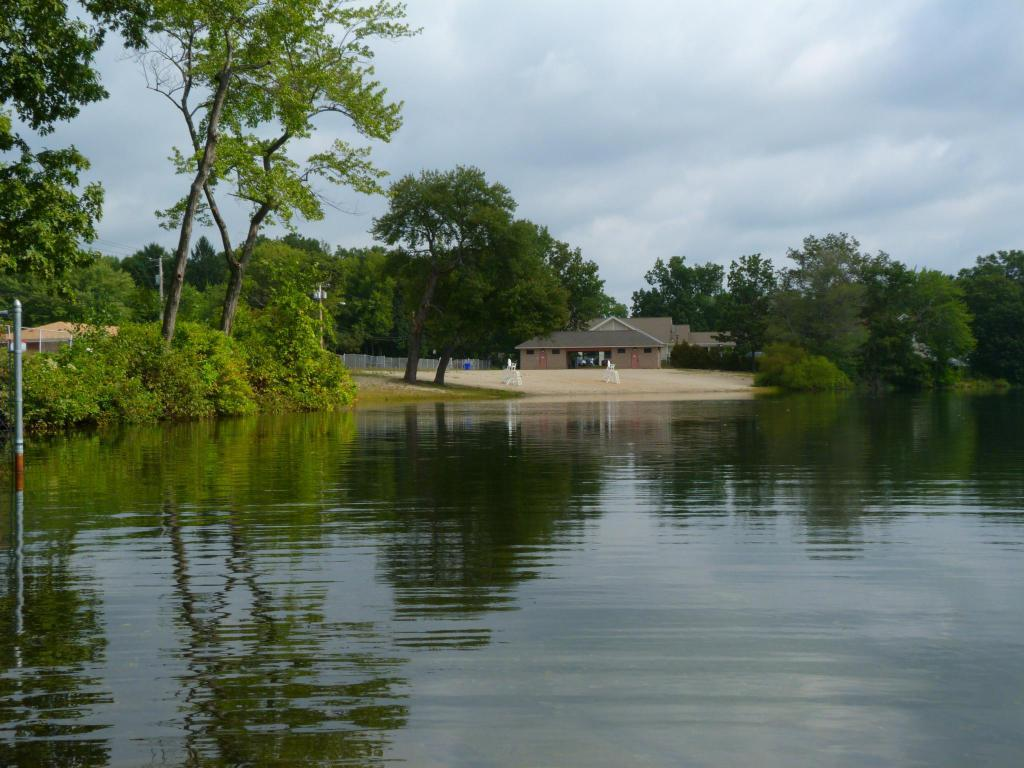What is at the bottom of the image? There are waves and water at the bottom of the image. What can be seen in the middle of the image? There are trees, a pole, a house, and land in the middle of the image. What is visible at the top of the image? There is sky visible at the top of the image, with clouds present. Can you see any horses ploughing the land in the image? There are no horses or ploughing activity present in the image. Is the land covered in snow in the image? There is no snow visible in the image; the land appears to be clear. 